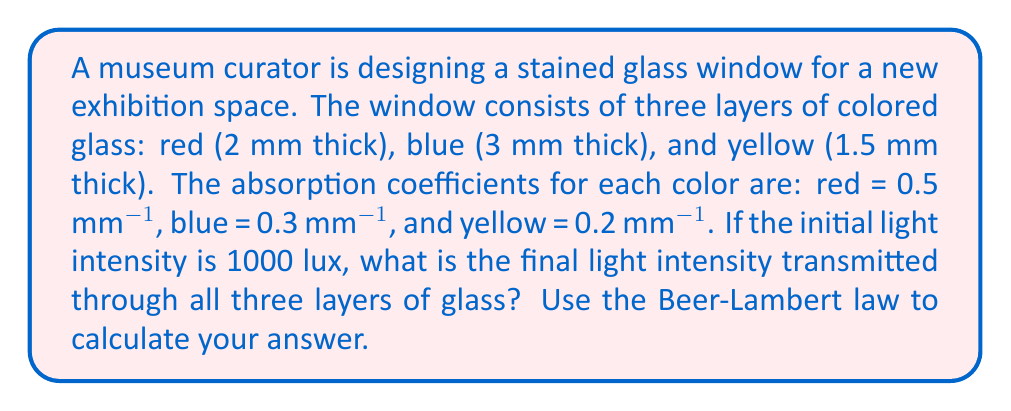Could you help me with this problem? To solve this problem, we'll use the Beer-Lambert law, which describes how light is absorbed as it passes through a material. The law is given by:

$$I = I_0 e^{-\alpha x}$$

Where:
$I$ is the transmitted light intensity
$I_0$ is the initial light intensity
$\alpha$ is the absorption coefficient
$x$ is the thickness of the material

We need to apply this law for each layer of glass and then multiply the results to get the final transmitted intensity.

1. For the red glass:
   $I_1 = 1000 \cdot e^{-0.5 \cdot 2} = 1000 \cdot e^{-1} \approx 367.88$ lux

2. For the blue glass:
   $I_2 = 367.88 \cdot e^{-0.3 \cdot 3} = 367.88 \cdot e^{-0.9} \approx 150.29$ lux

3. For the yellow glass:
   $I_3 = 150.29 \cdot e^{-0.2 \cdot 1.5} = 150.29 \cdot e^{-0.3} \approx 111.37$ lux

The final transmitted light intensity is approximately 111.37 lux.
Answer: 111.37 lux 